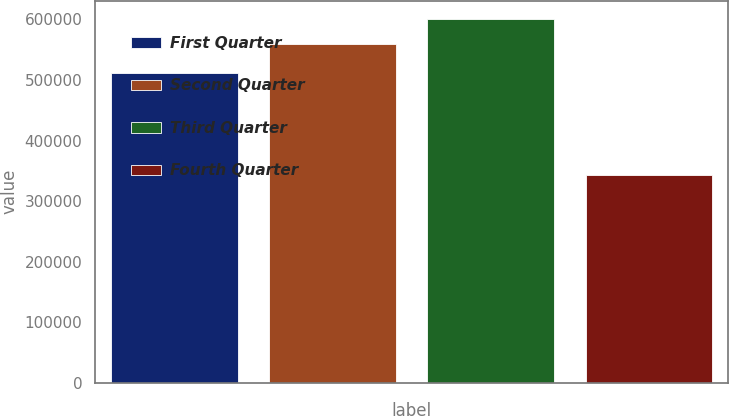Convert chart. <chart><loc_0><loc_0><loc_500><loc_500><bar_chart><fcel>First Quarter<fcel>Second Quarter<fcel>Third Quarter<fcel>Fourth Quarter<nl><fcel>510891<fcel>558738<fcel>600909<fcel>342696<nl></chart> 